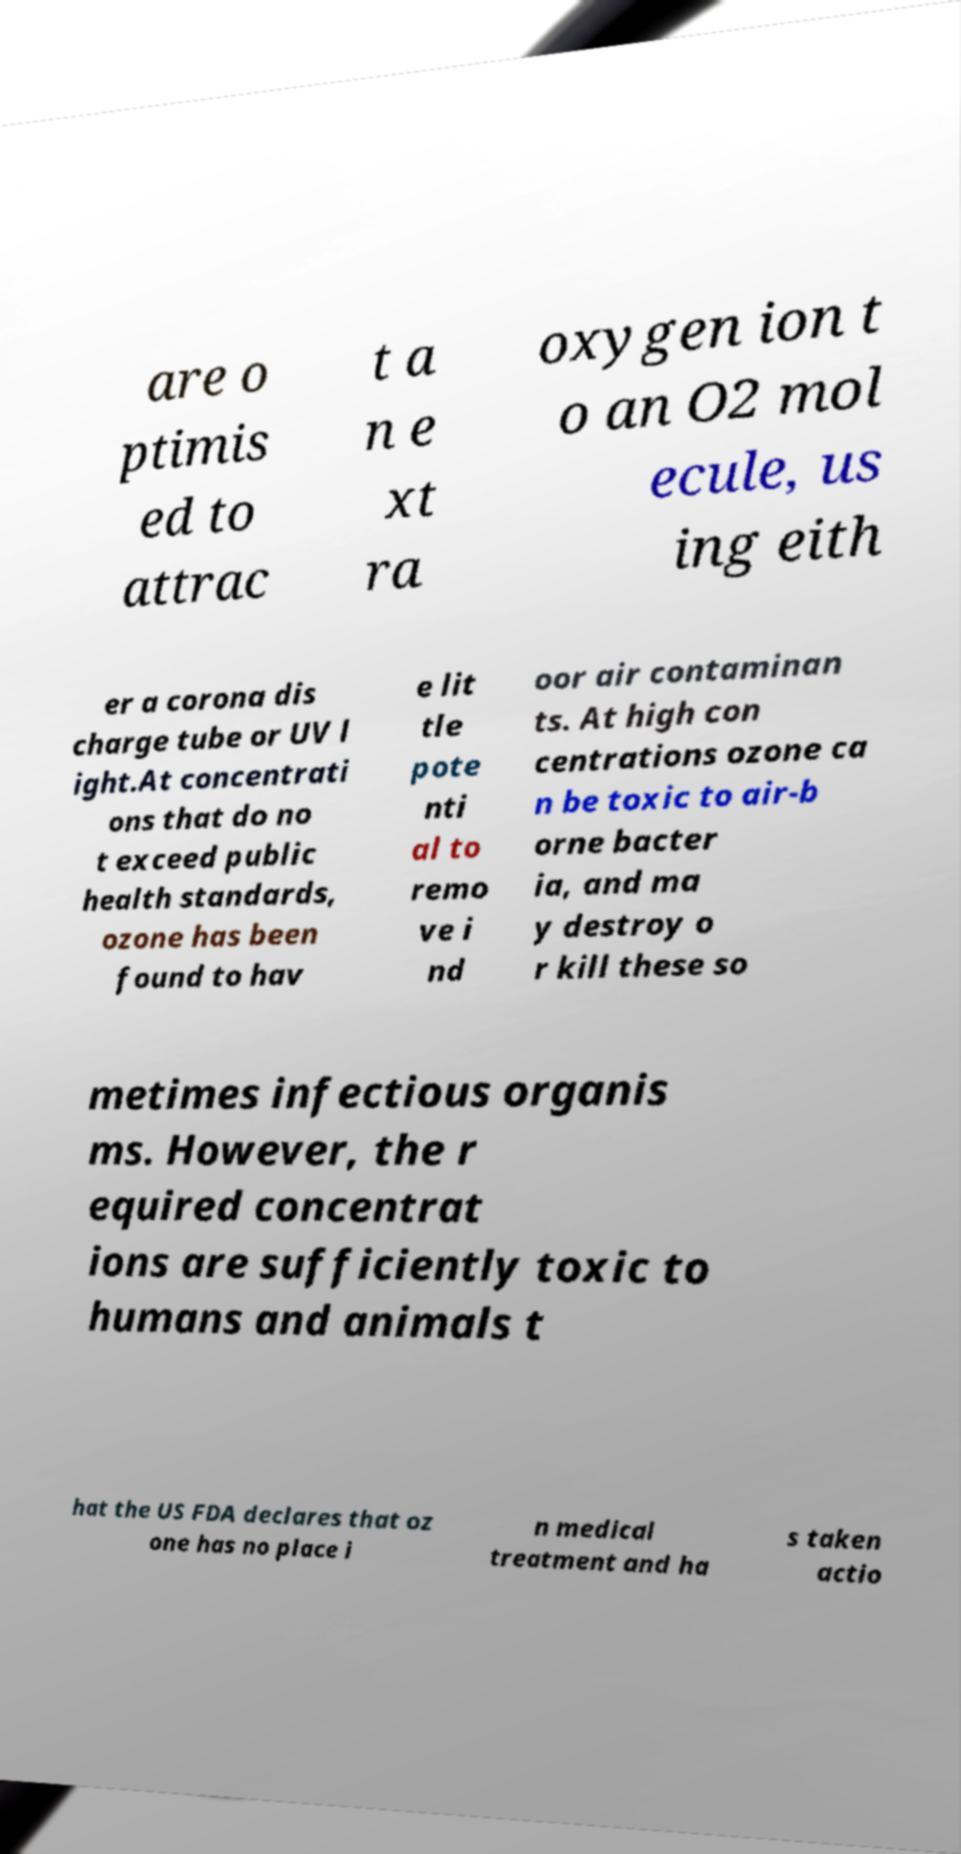Please identify and transcribe the text found in this image. are o ptimis ed to attrac t a n e xt ra oxygen ion t o an O2 mol ecule, us ing eith er a corona dis charge tube or UV l ight.At concentrati ons that do no t exceed public health standards, ozone has been found to hav e lit tle pote nti al to remo ve i nd oor air contaminan ts. At high con centrations ozone ca n be toxic to air-b orne bacter ia, and ma y destroy o r kill these so metimes infectious organis ms. However, the r equired concentrat ions are sufficiently toxic to humans and animals t hat the US FDA declares that oz one has no place i n medical treatment and ha s taken actio 